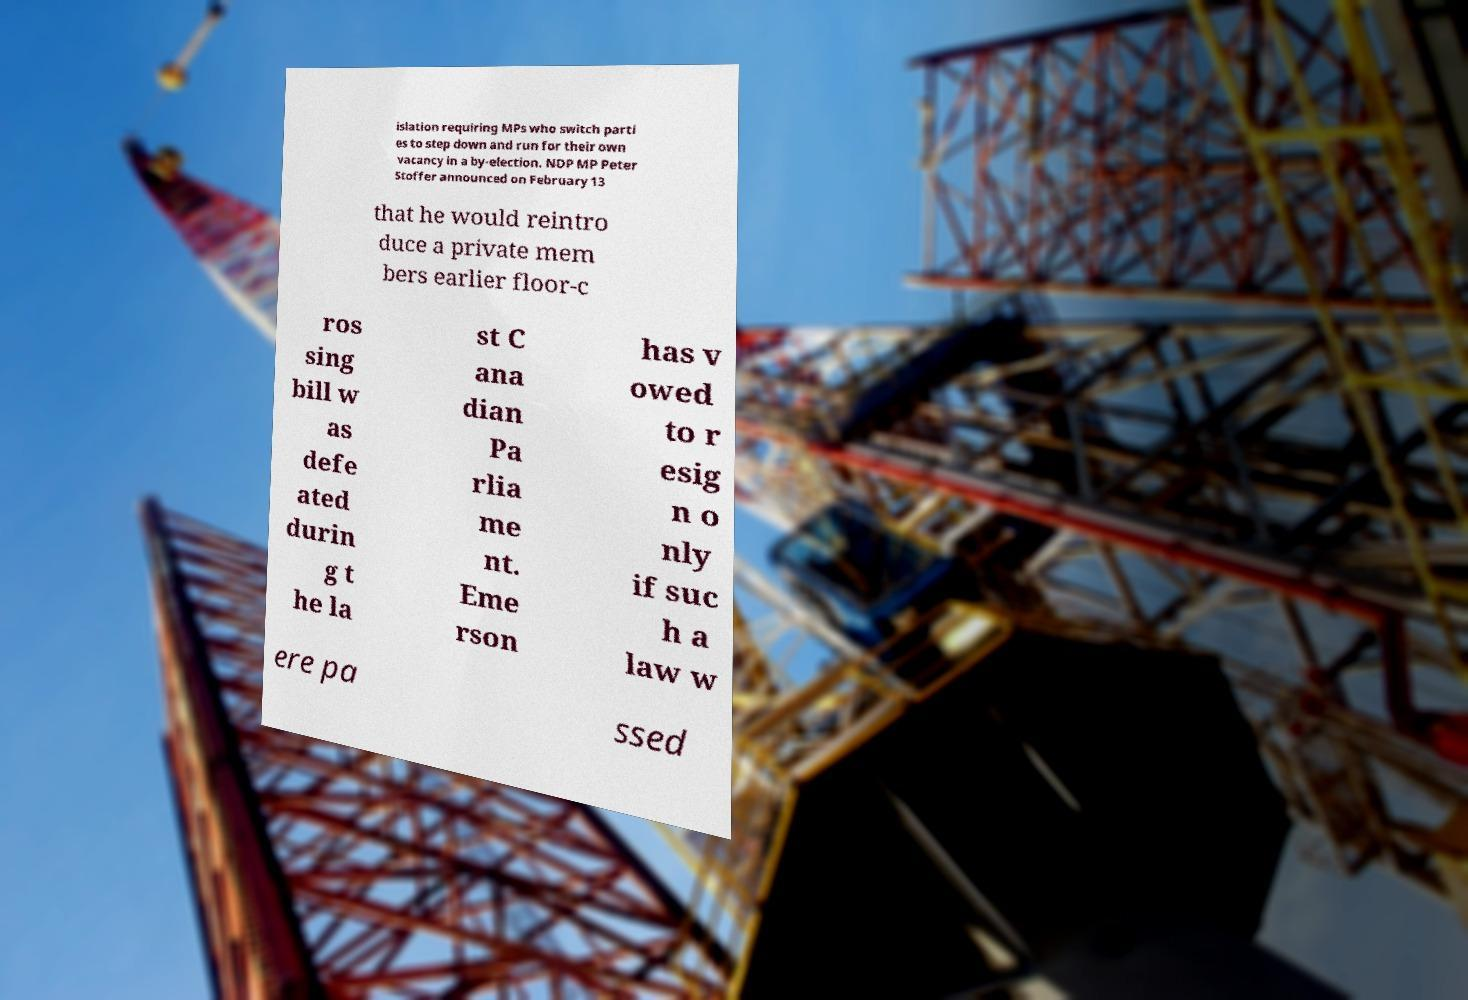Can you read and provide the text displayed in the image?This photo seems to have some interesting text. Can you extract and type it out for me? islation requiring MPs who switch parti es to step down and run for their own vacancy in a by-election. NDP MP Peter Stoffer announced on February 13 that he would reintro duce a private mem bers earlier floor-c ros sing bill w as defe ated durin g t he la st C ana dian Pa rlia me nt. Eme rson has v owed to r esig n o nly if suc h a law w ere pa ssed 